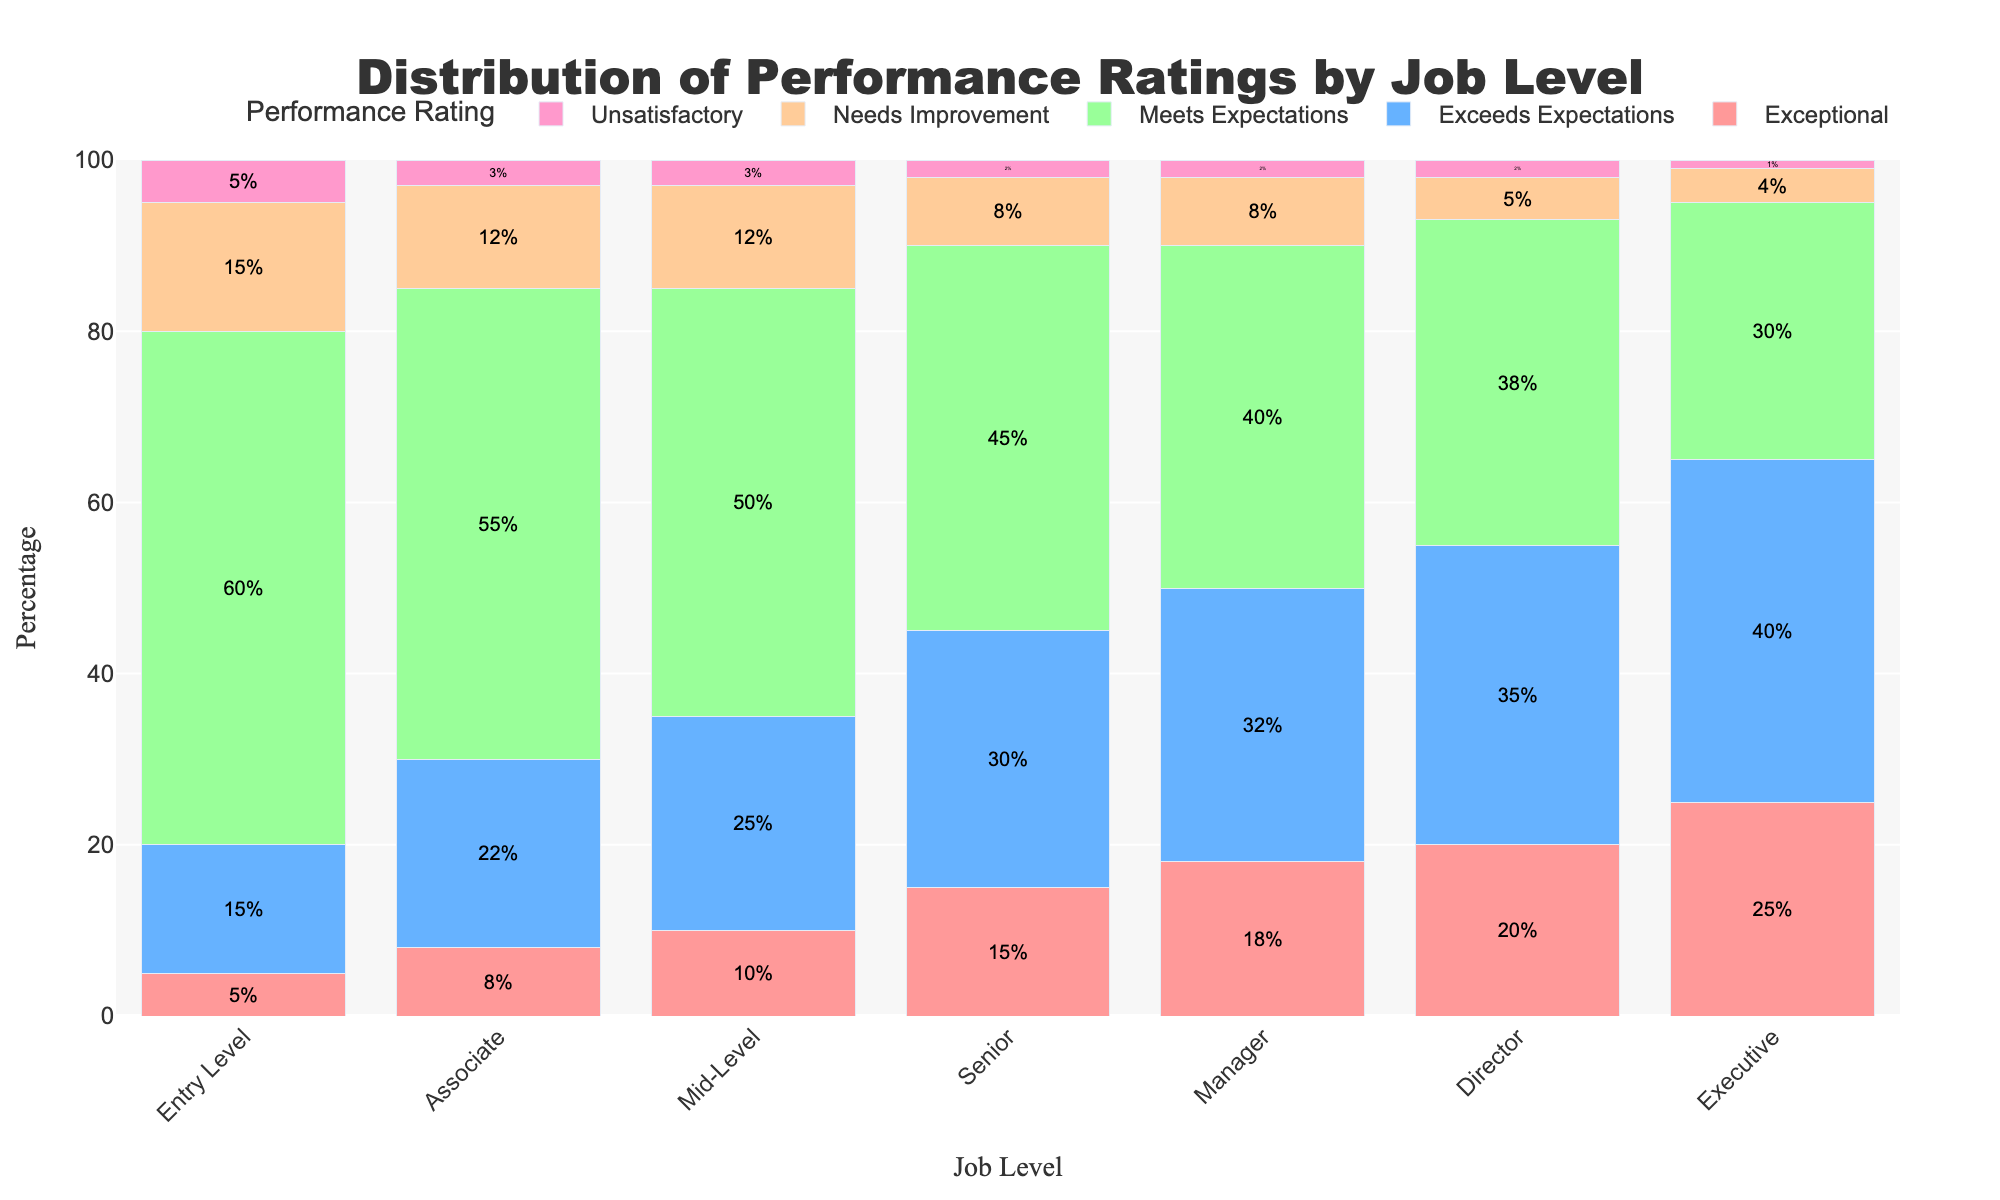What is the job level with the highest percentage of "Exceptional" performance ratings? Look at the "Exceptional" category for each job level and compare the percentages. The highest percentage is at the Executive level.
Answer: Executive How does the percentage of "Needs Improvement" ratings compare between Entry Level and Associate level positions? The "Needs Improvement" percentage for Entry Level is 15%, while for Associates it is 12%. 15% is greater than 12%, so Entry Level has a higher percentage.
Answer: Entry Level Which job level has the lowest percentage of "Meets Expectations" performance ratings? Look at the "Meets Expectations" category for each job level and find the lowest percentage. The Director level has the lowest percentage at 38%.
Answer: Director What is the total percentage of employees receiving "Exceeds Expectations" performance ratings in Senior and Manager levels? Sum the "Exceeds Expectations" percentages for Senior and Manager levels (30% + 32%) == 62%.
Answer: 62% How does the "Unsatisfactory" rating percentage change from Mid-Level to Executive level? Check the "Unsatisfactory" rating percentages for Mid-Level (3%), Senior (2%), Manager (2%), Director (2%), and Executive (1%). There is a decrease from 3% to 1% as you move from Mid-Level to Executive.
Answer: Decreases For what job levels is the percentage of "Exceptional" performance ratings greater than the percentage of "Meets Expectations"? Compare "Exceptional" and "Meets Expectations" percentages for each job level. None of the job levels meet this criteria as the percentage of "Meets Expectations" is always higher.
Answer: None Which job level has the most balanced distribution of performance ratings across the five categories? Look for the job level where the heights of the bars are more uniform. Entry Level (5%, 15%, 60%, 15%, 5%) appears the most balanced compared to others.
Answer: Entry Level What is the average percentage of "Exceeds Expectations" ratings across all job levels? Sum the percentages for "Exceeds Expectations" across job levels (15+22+25+30+32+35+40) and divide by 7. (15+22+25+30+32+35+40) / 7 = 28.428.
Answer: 28.43 Compare the combined percentage of "Needs Improvement" and "Unsatisfactory" ratings between Associate and Mid-Level positions. Sum "Needs Improvement" and "Unsatisfactory" ratings for both levels: Associate (12 + 3) = 15% and Mid-Level (12 + 3) = 15%.
Answer: Equal What trend do you observe in the percentage of "Exceptional" ratings as you move from Entry Level to Executive? Observe how the "Exceptional" rating percentage changes from Entry Level (5%) to Executive (25%). There is an increasing trend.
Answer: Increasing 